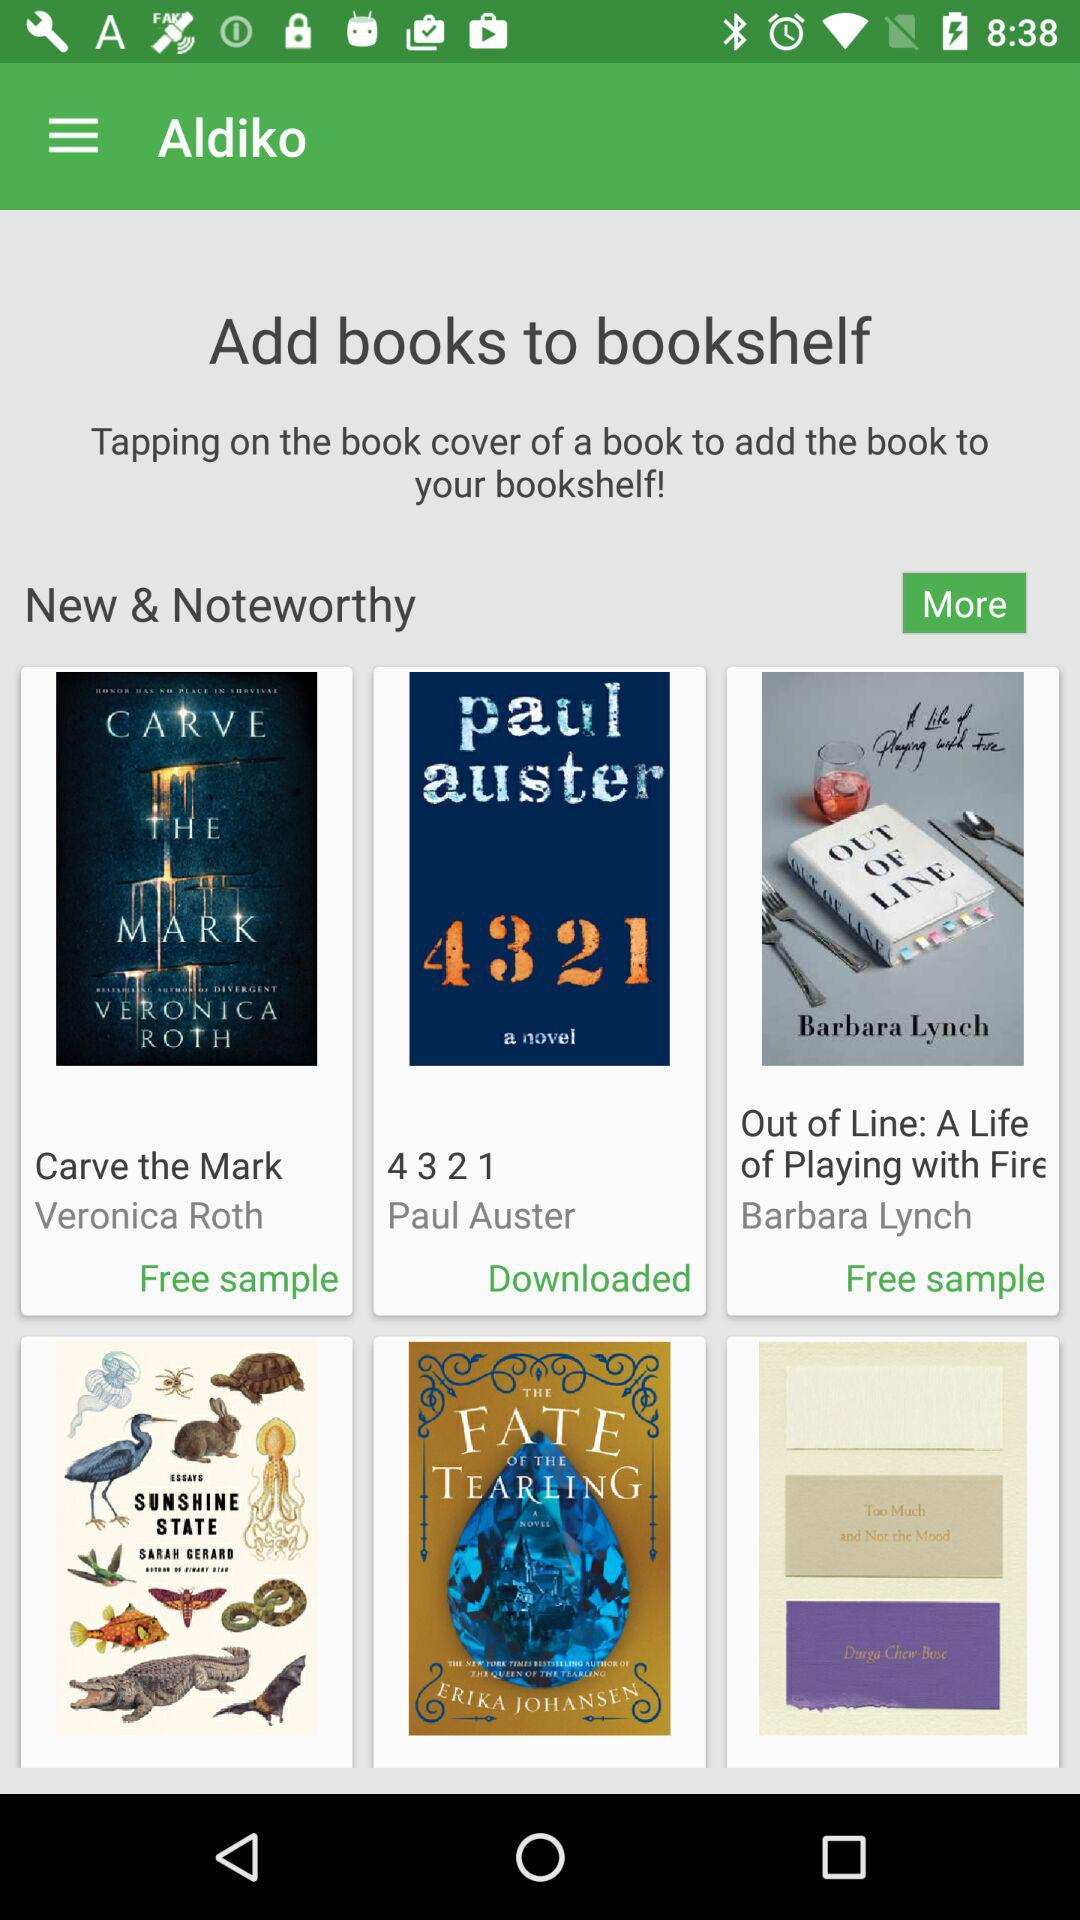What are the names of the free sample books? The names of the free sample books are "Carve the Mark", "4 3 2 1" and "Out of Line: A Life of Playing with Fire". 